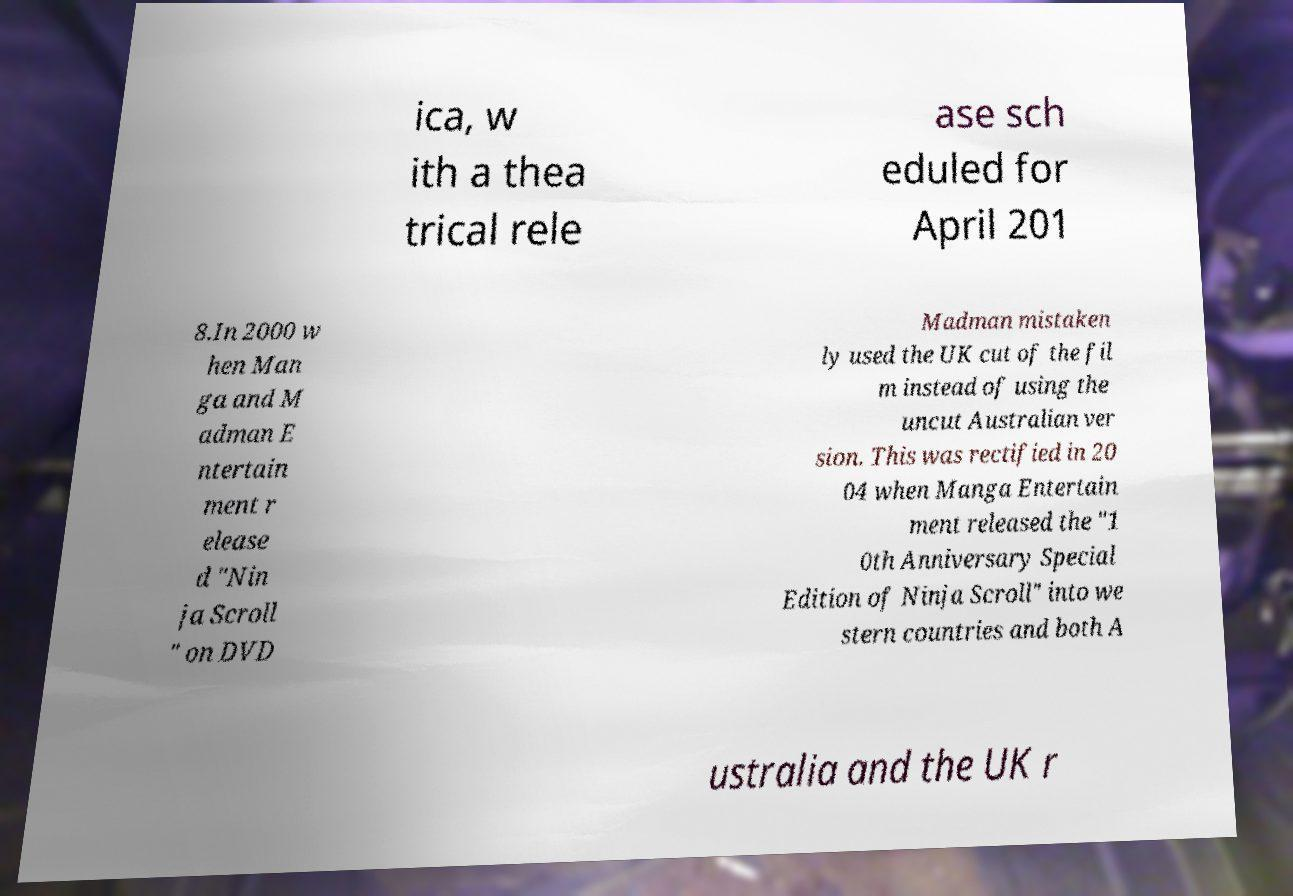Can you accurately transcribe the text from the provided image for me? ica, w ith a thea trical rele ase sch eduled for April 201 8.In 2000 w hen Man ga and M adman E ntertain ment r elease d "Nin ja Scroll " on DVD Madman mistaken ly used the UK cut of the fil m instead of using the uncut Australian ver sion. This was rectified in 20 04 when Manga Entertain ment released the "1 0th Anniversary Special Edition of Ninja Scroll" into we stern countries and both A ustralia and the UK r 